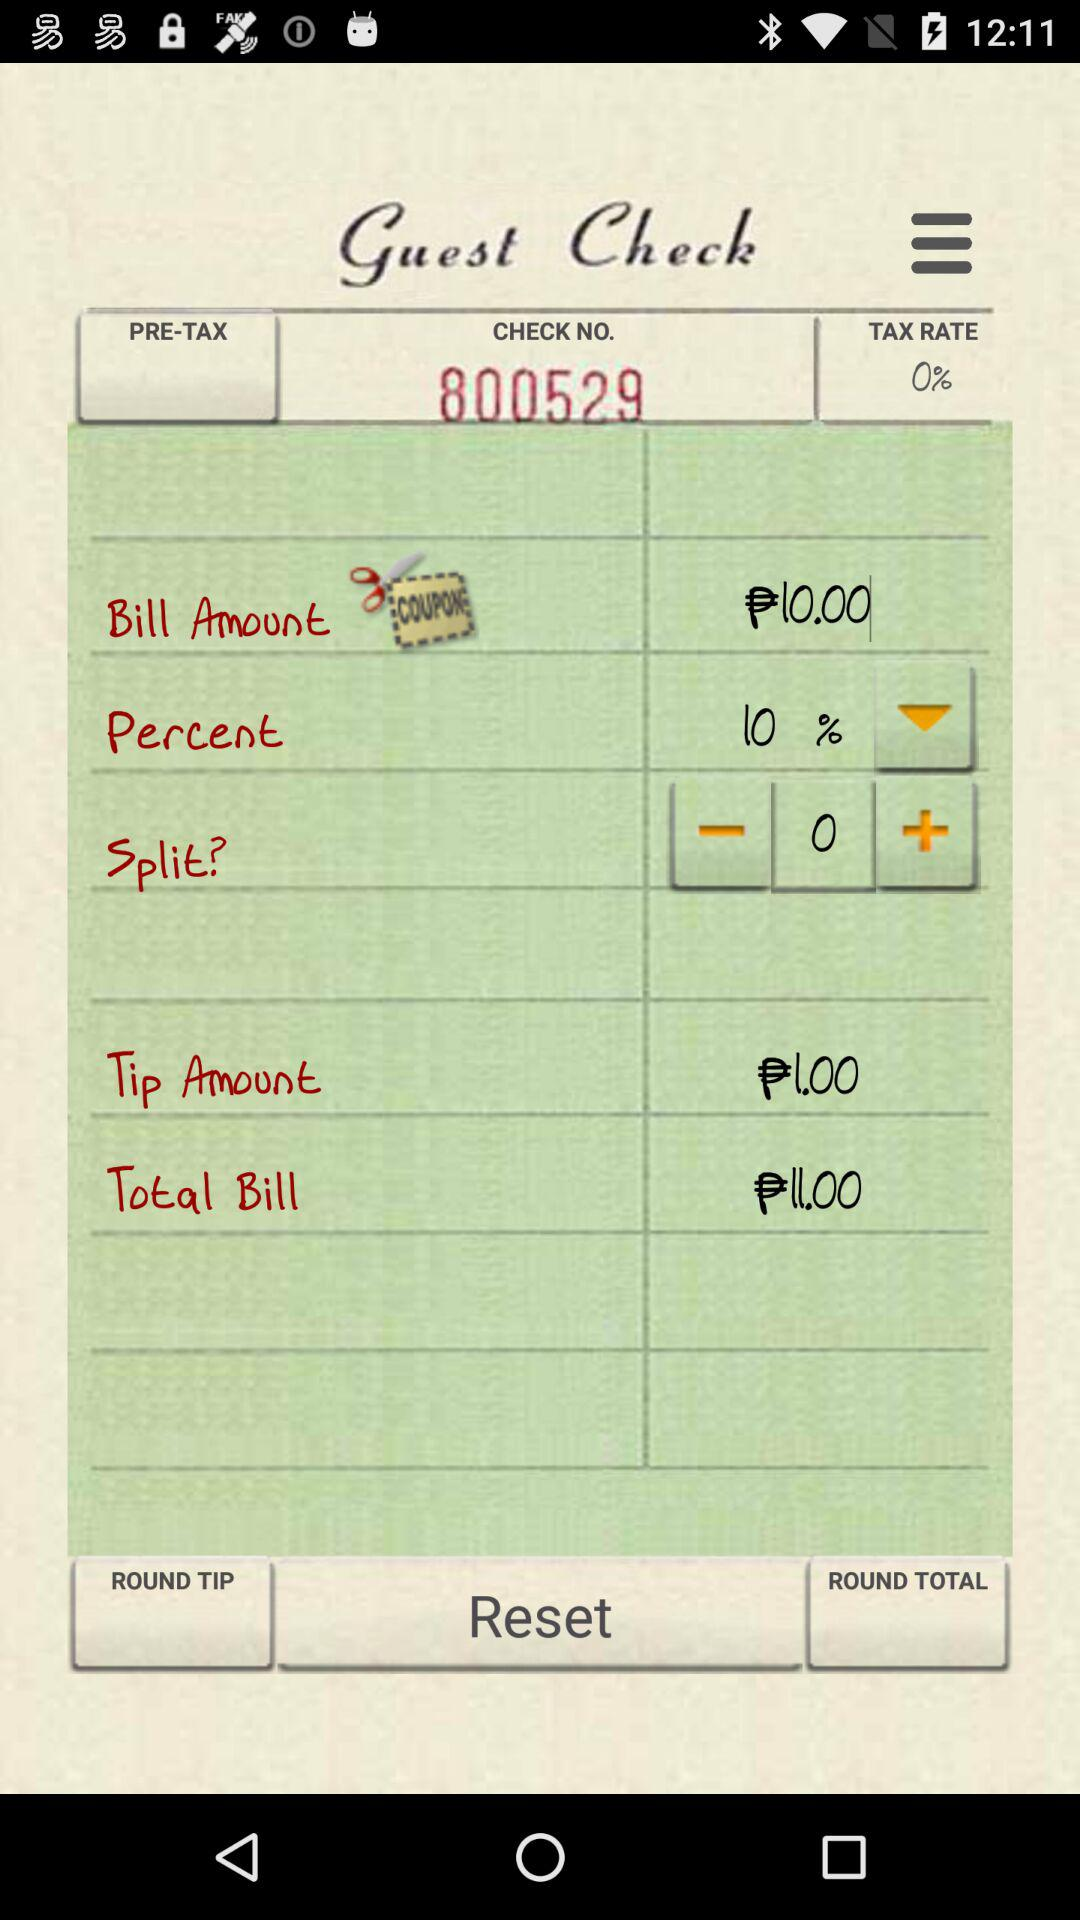What is the tip amount? The tip amount is ₱1. 